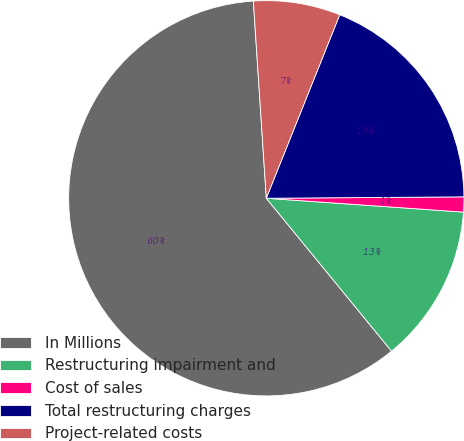<chart> <loc_0><loc_0><loc_500><loc_500><pie_chart><fcel>In Millions<fcel>Restructuring impairment and<fcel>Cost of sales<fcel>Total restructuring charges<fcel>Project-related costs<nl><fcel>59.88%<fcel>12.96%<fcel>1.23%<fcel>18.83%<fcel>7.1%<nl></chart> 